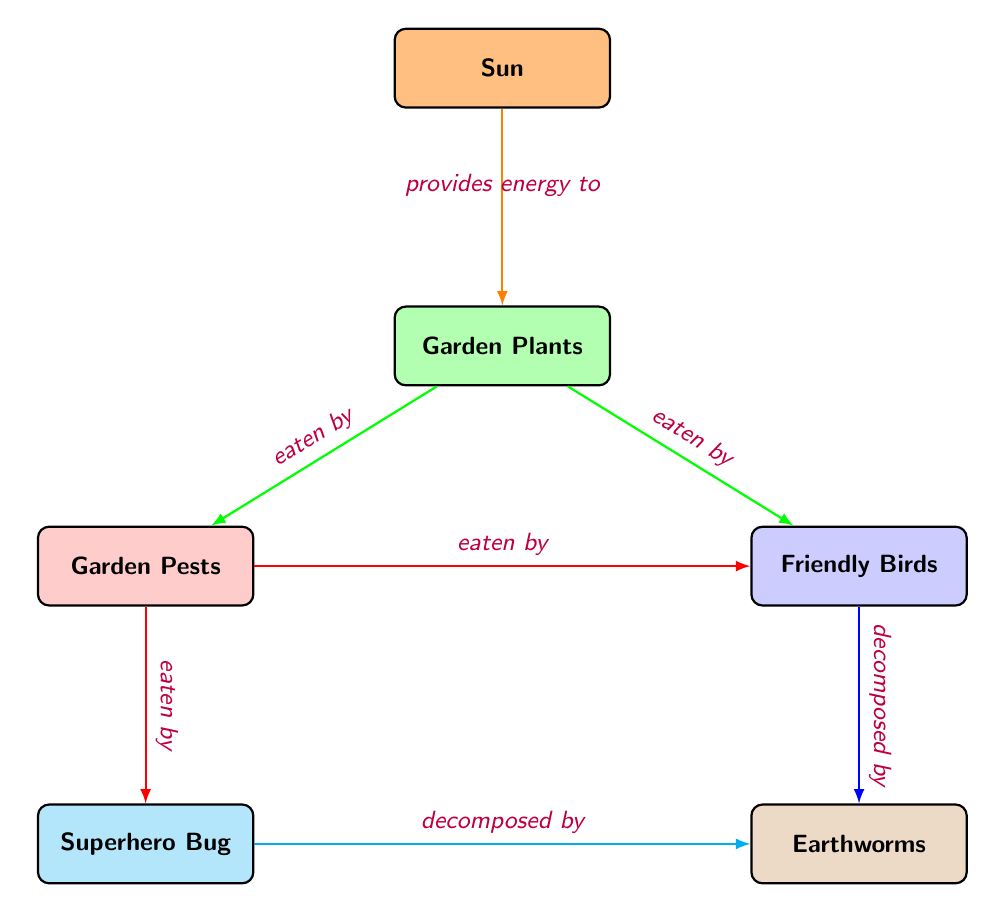What's the top node in the diagram? The top node represents the beginning of the food chain, and in this diagram, it indicates the source of energy. Tracing from the top down, the first block is labeled "Sun", which provides energy to the plants below.
Answer: Sun How many nodes are in the diagram? To find the number of nodes, we count each unique block in the diagram. There are six blocks: Sun, Garden Plants, Garden Pests, Friendly Birds, Superhero Bug, and Earthworms. This gives us a total of six nodes.
Answer: 6 Which node do the Friendly Birds eat from? The Friendly Birds eat from the Garden Plants. By following the arrows in the diagram, we see that there is a direct line from the Garden Plants to the Friendly Birds, indicating this relationship.
Answer: Garden Plants What do Earthworms decompose? Earthworms decompose both the Friendly Birds and the Superhero Bug according to the arrows leading to the Earthworms node. We can see arrows from each of these nodes pointing towards the decomposers.
Answer: Friendly Birds and Superhero Bug How many arrows come from the Garden Pests? We can observe the Garden Pests node and the arrows leading from it. There are two arrows coming out from the Garden Pests: one pointing to the Friendly Birds and the other to the Superhero Bug.
Answer: 2 Which node is related to energy flow in the diagram? The energy flow begins with the Sun, which is indicated by the arrow pointing down towards the Garden Plants. The diagram establishes a clear flow of energy starting from the Sun down to the plants.
Answer: Sun Which type of animals are the Garden Pests? The Garden Pests are classified as herbivores, as indicated by the labeling in the diagram. They directly eat the Garden Plants.
Answer: Herbivores What type of relationship exists between the Friendly Birds and the Garden Plants? The relationship is predatory, where the Friendly Birds eat the Garden Plants. This can be confirmed by tracing the arrow from the Garden Plants to the Friendly Birds, indicating that they are consumed by them.
Answer: Eaten by 